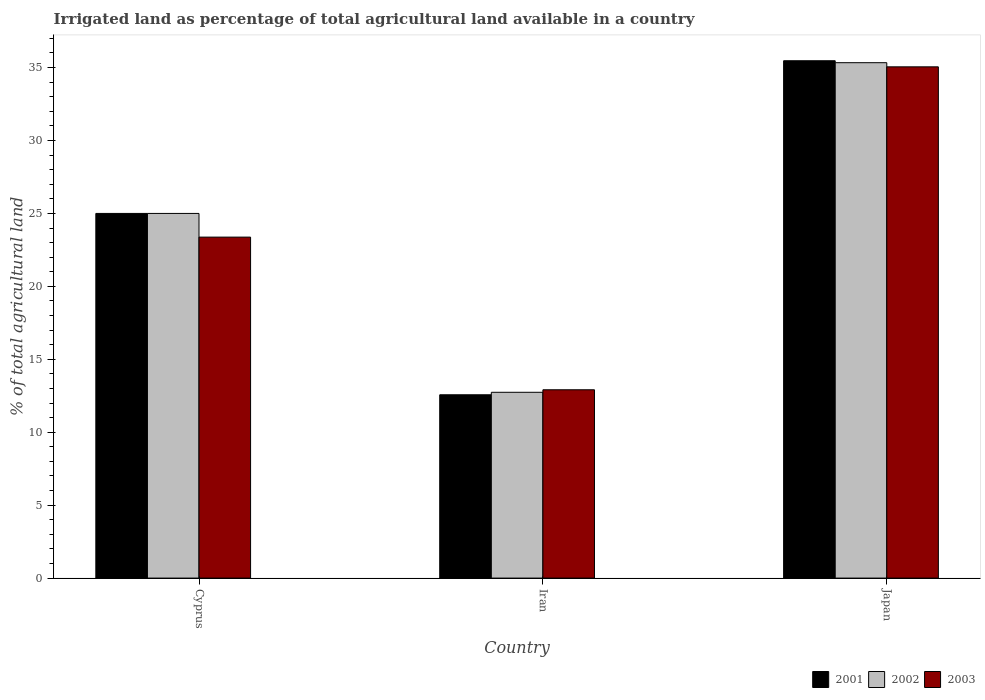How many different coloured bars are there?
Your answer should be compact. 3. How many groups of bars are there?
Your response must be concise. 3. How many bars are there on the 2nd tick from the right?
Keep it short and to the point. 3. What is the label of the 2nd group of bars from the left?
Ensure brevity in your answer.  Iran. What is the percentage of irrigated land in 2002 in Iran?
Your answer should be very brief. 12.74. Across all countries, what is the maximum percentage of irrigated land in 2001?
Your response must be concise. 35.47. Across all countries, what is the minimum percentage of irrigated land in 2001?
Keep it short and to the point. 12.57. In which country was the percentage of irrigated land in 2002 maximum?
Offer a very short reply. Japan. In which country was the percentage of irrigated land in 2002 minimum?
Ensure brevity in your answer.  Iran. What is the total percentage of irrigated land in 2003 in the graph?
Provide a succinct answer. 71.34. What is the difference between the percentage of irrigated land in 2001 in Cyprus and that in Iran?
Your response must be concise. 12.43. What is the difference between the percentage of irrigated land in 2003 in Iran and the percentage of irrigated land in 2001 in Japan?
Give a very brief answer. -22.56. What is the average percentage of irrigated land in 2003 per country?
Offer a terse response. 23.78. What is the difference between the percentage of irrigated land of/in 2001 and percentage of irrigated land of/in 2002 in Japan?
Offer a very short reply. 0.13. In how many countries, is the percentage of irrigated land in 2002 greater than 9 %?
Ensure brevity in your answer.  3. What is the ratio of the percentage of irrigated land in 2001 in Cyprus to that in Japan?
Your answer should be compact. 0.7. Is the difference between the percentage of irrigated land in 2001 in Cyprus and Iran greater than the difference between the percentage of irrigated land in 2002 in Cyprus and Iran?
Your answer should be compact. Yes. What is the difference between the highest and the second highest percentage of irrigated land in 2001?
Offer a very short reply. -10.47. What is the difference between the highest and the lowest percentage of irrigated land in 2002?
Keep it short and to the point. 22.6. In how many countries, is the percentage of irrigated land in 2001 greater than the average percentage of irrigated land in 2001 taken over all countries?
Give a very brief answer. 2. What does the 2nd bar from the left in Japan represents?
Provide a short and direct response. 2002. What does the 3rd bar from the right in Iran represents?
Your answer should be very brief. 2001. Are all the bars in the graph horizontal?
Give a very brief answer. No. What is the difference between two consecutive major ticks on the Y-axis?
Provide a succinct answer. 5. Does the graph contain any zero values?
Your answer should be compact. No. Does the graph contain grids?
Make the answer very short. No. Where does the legend appear in the graph?
Offer a very short reply. Bottom right. How many legend labels are there?
Give a very brief answer. 3. What is the title of the graph?
Keep it short and to the point. Irrigated land as percentage of total agricultural land available in a country. Does "1997" appear as one of the legend labels in the graph?
Your answer should be compact. No. What is the label or title of the Y-axis?
Your answer should be very brief. % of total agricultural land. What is the % of total agricultural land of 2001 in Cyprus?
Provide a succinct answer. 25. What is the % of total agricultural land in 2003 in Cyprus?
Your answer should be compact. 23.38. What is the % of total agricultural land of 2001 in Iran?
Ensure brevity in your answer.  12.57. What is the % of total agricultural land of 2002 in Iran?
Give a very brief answer. 12.74. What is the % of total agricultural land in 2003 in Iran?
Your response must be concise. 12.91. What is the % of total agricultural land of 2001 in Japan?
Give a very brief answer. 35.47. What is the % of total agricultural land of 2002 in Japan?
Provide a short and direct response. 35.33. What is the % of total agricultural land of 2003 in Japan?
Give a very brief answer. 35.05. Across all countries, what is the maximum % of total agricultural land in 2001?
Give a very brief answer. 35.47. Across all countries, what is the maximum % of total agricultural land in 2002?
Give a very brief answer. 35.33. Across all countries, what is the maximum % of total agricultural land of 2003?
Provide a short and direct response. 35.05. Across all countries, what is the minimum % of total agricultural land of 2001?
Make the answer very short. 12.57. Across all countries, what is the minimum % of total agricultural land of 2002?
Keep it short and to the point. 12.74. Across all countries, what is the minimum % of total agricultural land in 2003?
Offer a terse response. 12.91. What is the total % of total agricultural land in 2001 in the graph?
Provide a succinct answer. 73.04. What is the total % of total agricultural land of 2002 in the graph?
Provide a short and direct response. 73.07. What is the total % of total agricultural land in 2003 in the graph?
Offer a terse response. 71.34. What is the difference between the % of total agricultural land of 2001 in Cyprus and that in Iran?
Give a very brief answer. 12.43. What is the difference between the % of total agricultural land in 2002 in Cyprus and that in Iran?
Ensure brevity in your answer.  12.26. What is the difference between the % of total agricultural land of 2003 in Cyprus and that in Iran?
Your answer should be compact. 10.47. What is the difference between the % of total agricultural land in 2001 in Cyprus and that in Japan?
Your response must be concise. -10.47. What is the difference between the % of total agricultural land in 2002 in Cyprus and that in Japan?
Provide a succinct answer. -10.33. What is the difference between the % of total agricultural land in 2003 in Cyprus and that in Japan?
Provide a succinct answer. -11.67. What is the difference between the % of total agricultural land in 2001 in Iran and that in Japan?
Make the answer very short. -22.9. What is the difference between the % of total agricultural land in 2002 in Iran and that in Japan?
Keep it short and to the point. -22.6. What is the difference between the % of total agricultural land in 2003 in Iran and that in Japan?
Provide a short and direct response. -22.14. What is the difference between the % of total agricultural land of 2001 in Cyprus and the % of total agricultural land of 2002 in Iran?
Keep it short and to the point. 12.26. What is the difference between the % of total agricultural land in 2001 in Cyprus and the % of total agricultural land in 2003 in Iran?
Your response must be concise. 12.09. What is the difference between the % of total agricultural land in 2002 in Cyprus and the % of total agricultural land in 2003 in Iran?
Offer a terse response. 12.09. What is the difference between the % of total agricultural land of 2001 in Cyprus and the % of total agricultural land of 2002 in Japan?
Offer a very short reply. -10.33. What is the difference between the % of total agricultural land of 2001 in Cyprus and the % of total agricultural land of 2003 in Japan?
Ensure brevity in your answer.  -10.05. What is the difference between the % of total agricultural land of 2002 in Cyprus and the % of total agricultural land of 2003 in Japan?
Your response must be concise. -10.05. What is the difference between the % of total agricultural land in 2001 in Iran and the % of total agricultural land in 2002 in Japan?
Make the answer very short. -22.77. What is the difference between the % of total agricultural land in 2001 in Iran and the % of total agricultural land in 2003 in Japan?
Provide a succinct answer. -22.48. What is the difference between the % of total agricultural land in 2002 in Iran and the % of total agricultural land in 2003 in Japan?
Ensure brevity in your answer.  -22.31. What is the average % of total agricultural land of 2001 per country?
Keep it short and to the point. 24.35. What is the average % of total agricultural land in 2002 per country?
Ensure brevity in your answer.  24.36. What is the average % of total agricultural land of 2003 per country?
Your answer should be very brief. 23.78. What is the difference between the % of total agricultural land of 2001 and % of total agricultural land of 2003 in Cyprus?
Provide a succinct answer. 1.62. What is the difference between the % of total agricultural land of 2002 and % of total agricultural land of 2003 in Cyprus?
Make the answer very short. 1.62. What is the difference between the % of total agricultural land of 2001 and % of total agricultural land of 2002 in Iran?
Provide a succinct answer. -0.17. What is the difference between the % of total agricultural land in 2001 and % of total agricultural land in 2003 in Iran?
Make the answer very short. -0.34. What is the difference between the % of total agricultural land in 2002 and % of total agricultural land in 2003 in Iran?
Give a very brief answer. -0.17. What is the difference between the % of total agricultural land in 2001 and % of total agricultural land in 2002 in Japan?
Ensure brevity in your answer.  0.13. What is the difference between the % of total agricultural land of 2001 and % of total agricultural land of 2003 in Japan?
Make the answer very short. 0.42. What is the difference between the % of total agricultural land of 2002 and % of total agricultural land of 2003 in Japan?
Keep it short and to the point. 0.28. What is the ratio of the % of total agricultural land in 2001 in Cyprus to that in Iran?
Offer a terse response. 1.99. What is the ratio of the % of total agricultural land in 2002 in Cyprus to that in Iran?
Offer a terse response. 1.96. What is the ratio of the % of total agricultural land of 2003 in Cyprus to that in Iran?
Your answer should be compact. 1.81. What is the ratio of the % of total agricultural land in 2001 in Cyprus to that in Japan?
Provide a short and direct response. 0.7. What is the ratio of the % of total agricultural land in 2002 in Cyprus to that in Japan?
Ensure brevity in your answer.  0.71. What is the ratio of the % of total agricultural land of 2003 in Cyprus to that in Japan?
Provide a short and direct response. 0.67. What is the ratio of the % of total agricultural land in 2001 in Iran to that in Japan?
Offer a terse response. 0.35. What is the ratio of the % of total agricultural land of 2002 in Iran to that in Japan?
Provide a short and direct response. 0.36. What is the ratio of the % of total agricultural land of 2003 in Iran to that in Japan?
Your answer should be compact. 0.37. What is the difference between the highest and the second highest % of total agricultural land in 2001?
Your answer should be compact. 10.47. What is the difference between the highest and the second highest % of total agricultural land in 2002?
Your answer should be compact. 10.33. What is the difference between the highest and the second highest % of total agricultural land of 2003?
Your answer should be compact. 11.67. What is the difference between the highest and the lowest % of total agricultural land in 2001?
Offer a very short reply. 22.9. What is the difference between the highest and the lowest % of total agricultural land in 2002?
Your answer should be compact. 22.6. What is the difference between the highest and the lowest % of total agricultural land in 2003?
Your response must be concise. 22.14. 